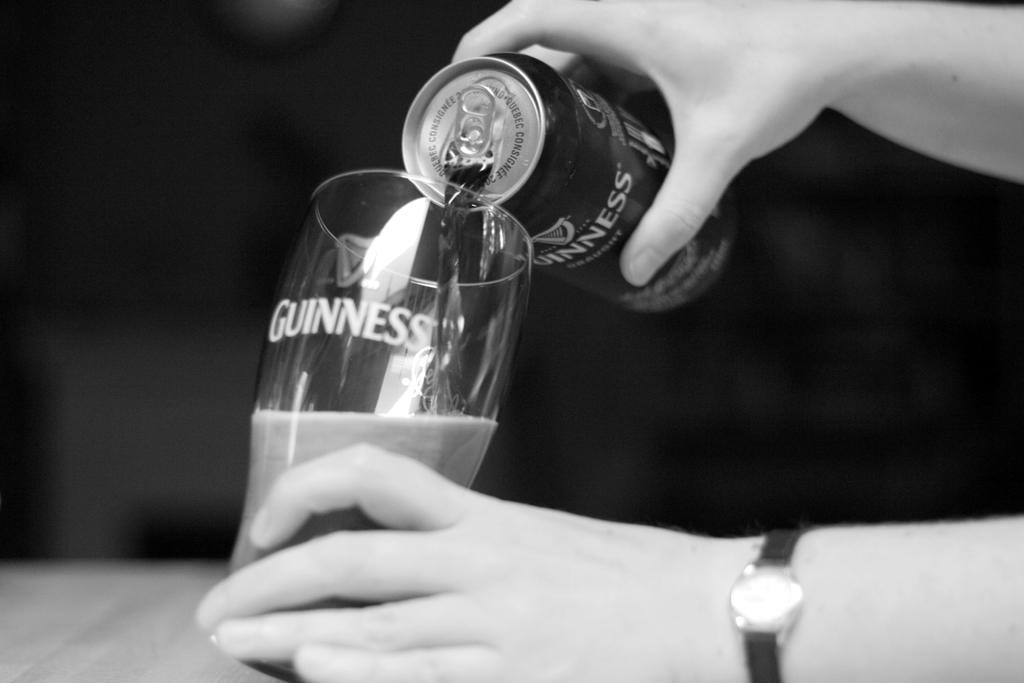Can you describe this image briefly? This is a black and white picture. Here we can see hands of a person holding a tin and a glass. And we can see pouring liquid from a tin into a glass. There is a dark background. 